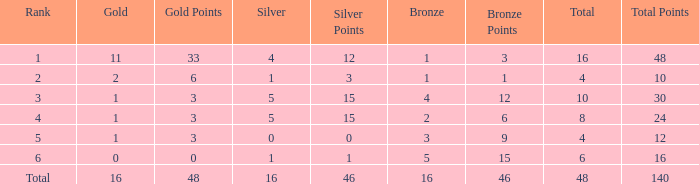How many total gold are less than 4? 0.0. 